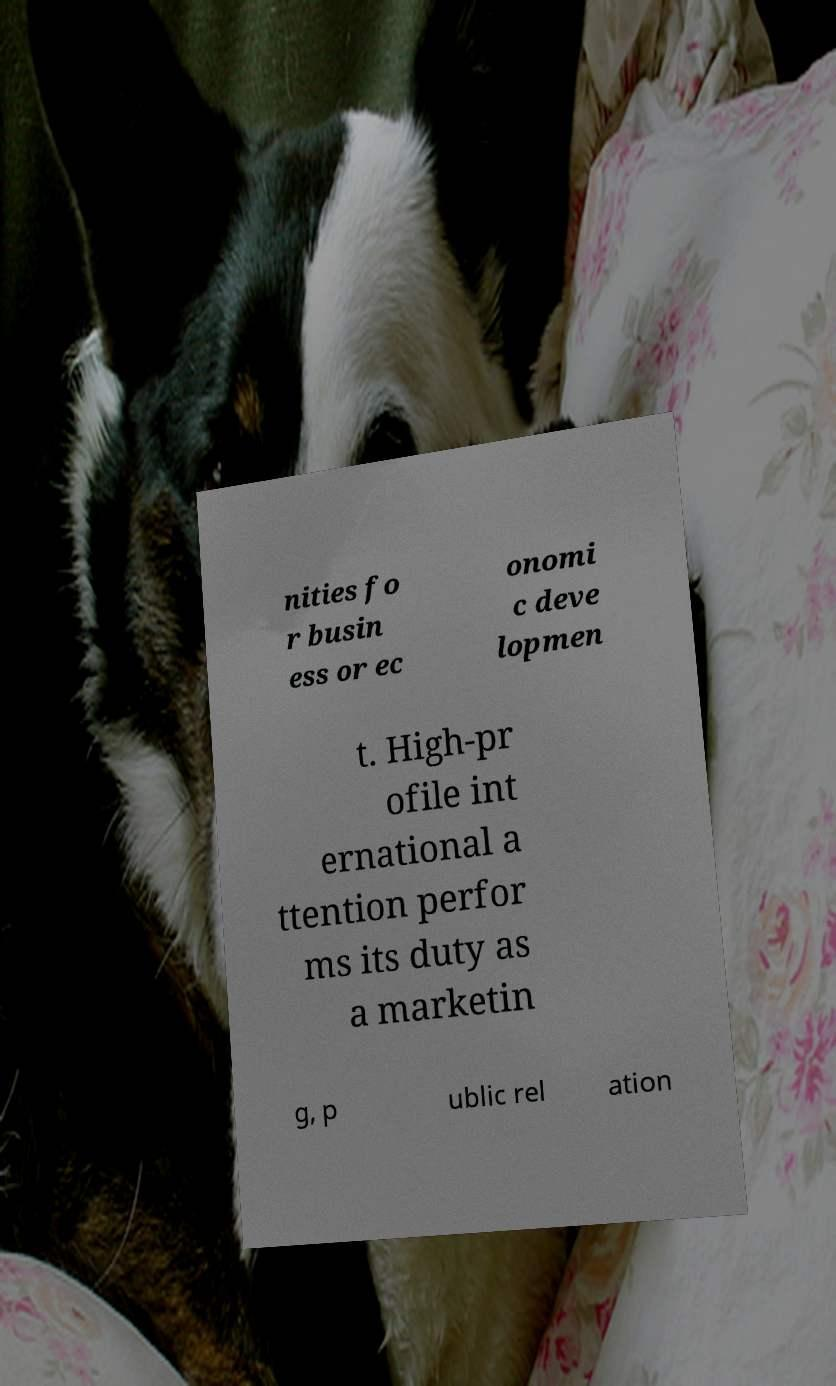Please identify and transcribe the text found in this image. nities fo r busin ess or ec onomi c deve lopmen t. High-pr ofile int ernational a ttention perfor ms its duty as a marketin g, p ublic rel ation 